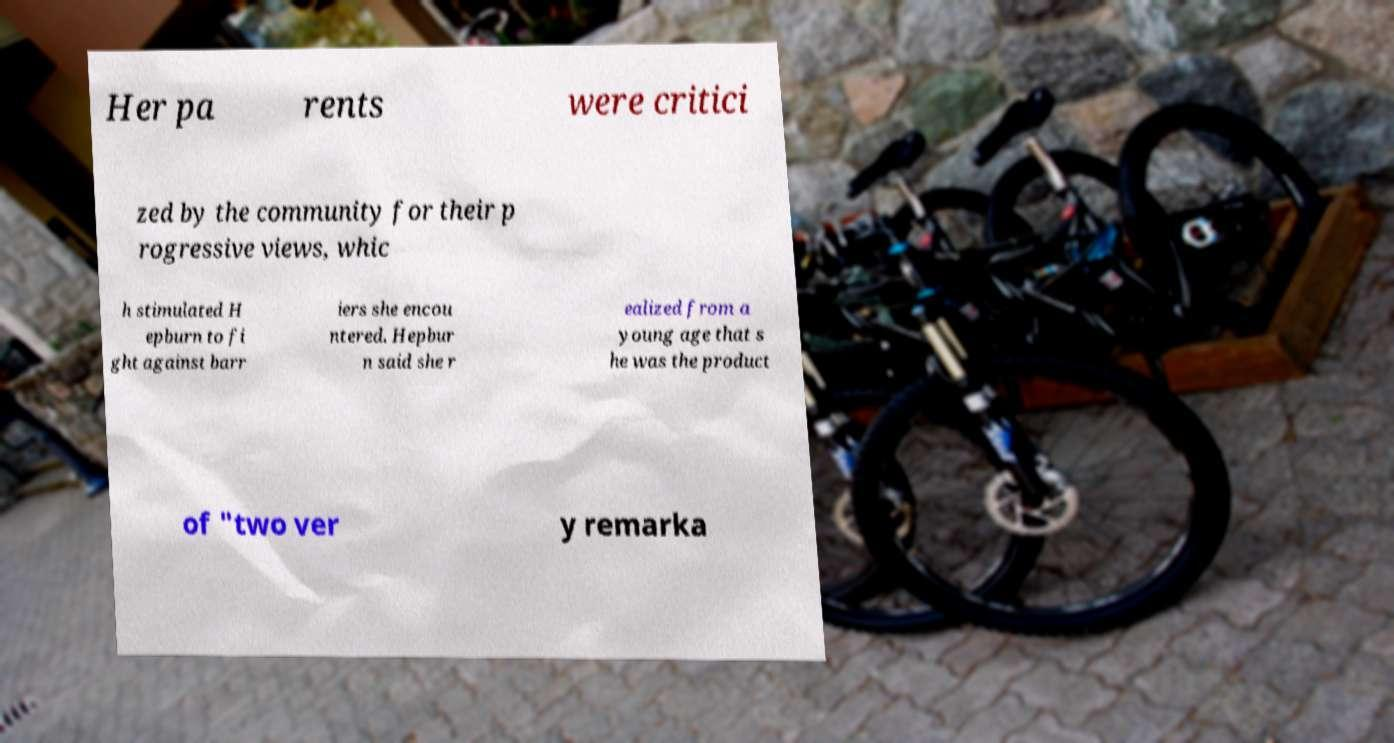What messages or text are displayed in this image? I need them in a readable, typed format. Her pa rents were critici zed by the community for their p rogressive views, whic h stimulated H epburn to fi ght against barr iers she encou ntered. Hepbur n said she r ealized from a young age that s he was the product of "two ver y remarka 